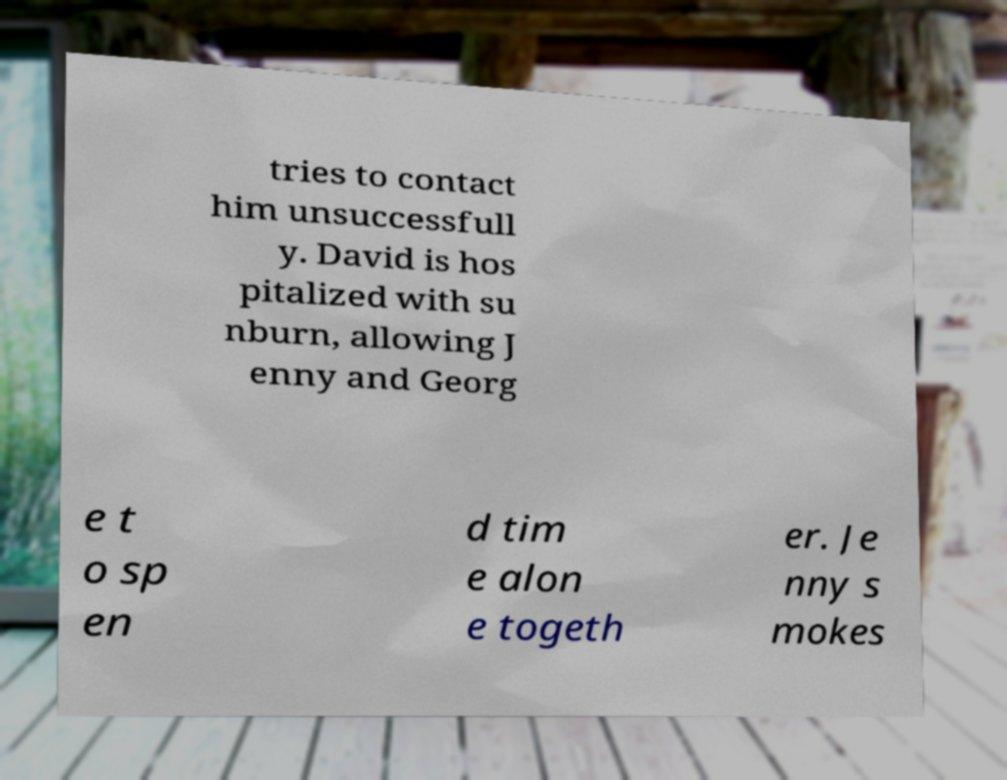I need the written content from this picture converted into text. Can you do that? tries to contact him unsuccessfull y. David is hos pitalized with su nburn, allowing J enny and Georg e t o sp en d tim e alon e togeth er. Je nny s mokes 